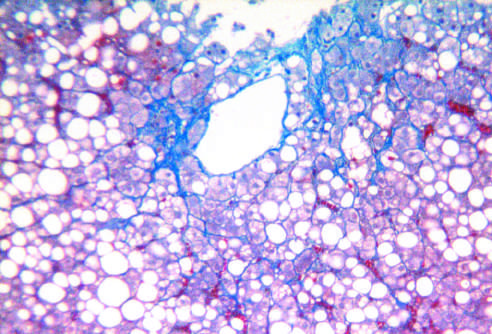s the normal gland acini associated with chronic alcohol use?
Answer the question using a single word or phrase. No 